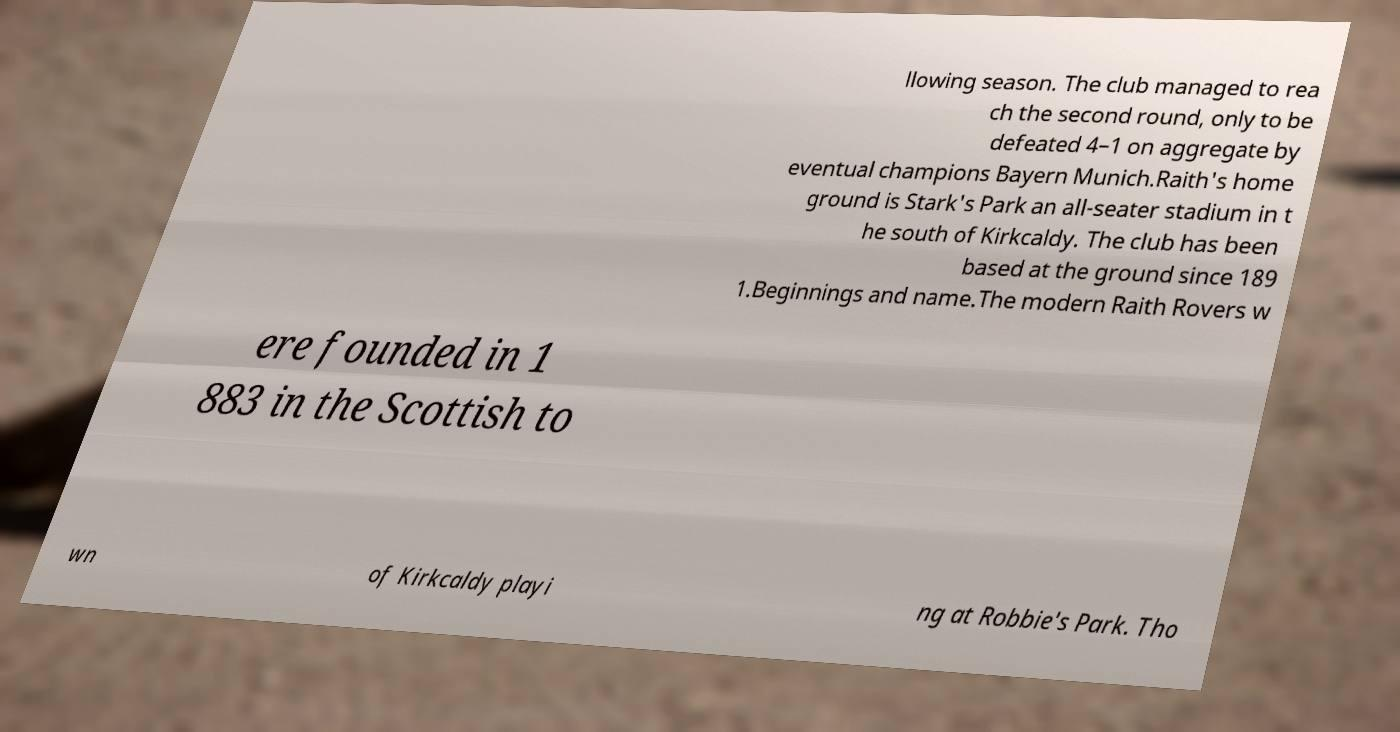Please read and relay the text visible in this image. What does it say? llowing season. The club managed to rea ch the second round, only to be defeated 4–1 on aggregate by eventual champions Bayern Munich.Raith's home ground is Stark's Park an all-seater stadium in t he south of Kirkcaldy. The club has been based at the ground since 189 1.Beginnings and name.The modern Raith Rovers w ere founded in 1 883 in the Scottish to wn of Kirkcaldy playi ng at Robbie's Park. Tho 